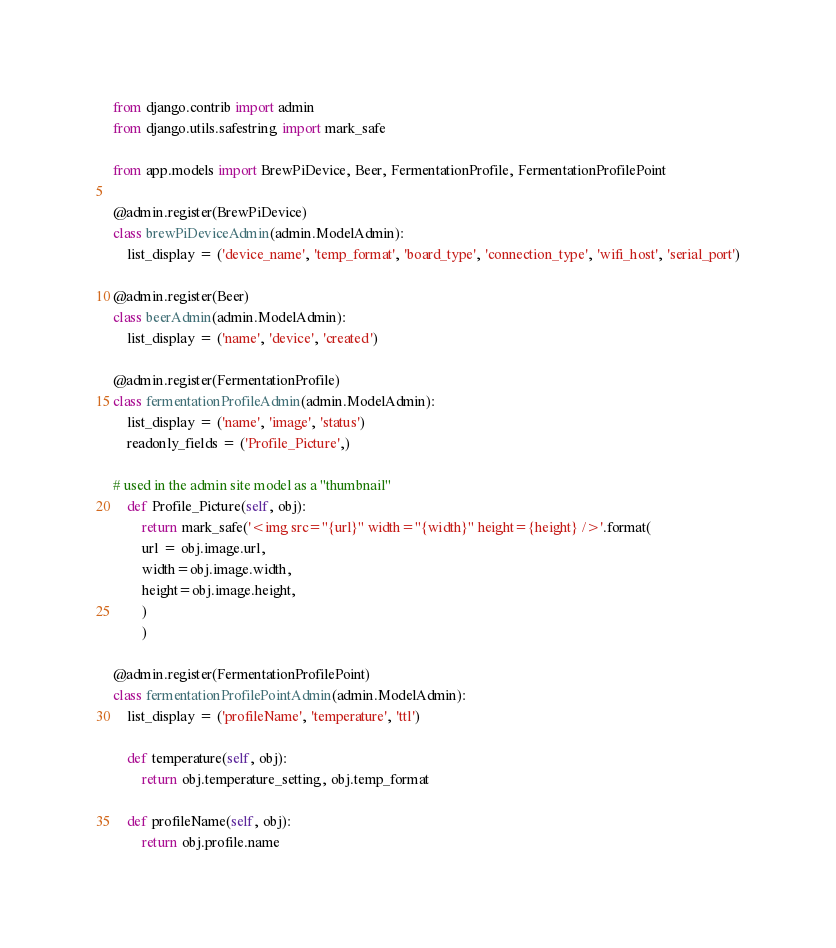Convert code to text. <code><loc_0><loc_0><loc_500><loc_500><_Python_>from django.contrib import admin
from django.utils.safestring import mark_safe

from app.models import BrewPiDevice, Beer, FermentationProfile, FermentationProfilePoint

@admin.register(BrewPiDevice)
class brewPiDeviceAdmin(admin.ModelAdmin):
    list_display = ('device_name', 'temp_format', 'board_type', 'connection_type', 'wifi_host', 'serial_port')

@admin.register(Beer)
class beerAdmin(admin.ModelAdmin):
    list_display = ('name', 'device', 'created')

@admin.register(FermentationProfile)
class fermentationProfileAdmin(admin.ModelAdmin):
    list_display = ('name', 'image', 'status')
    readonly_fields = ('Profile_Picture',)

# used in the admin site model as a "thumbnail"
    def Profile_Picture(self, obj):
        return mark_safe('<img src="{url}" width="{width}" height={height} />'.format(
        url = obj.image.url,
        width=obj.image.width,
        height=obj.image.height,
        )
        )

@admin.register(FermentationProfilePoint)
class fermentationProfilePointAdmin(admin.ModelAdmin):
    list_display = ('profileName', 'temperature', 'ttl')

    def temperature(self, obj):
        return obj.temperature_setting, obj.temp_format

    def profileName(self, obj):
        return obj.profile.name
</code> 